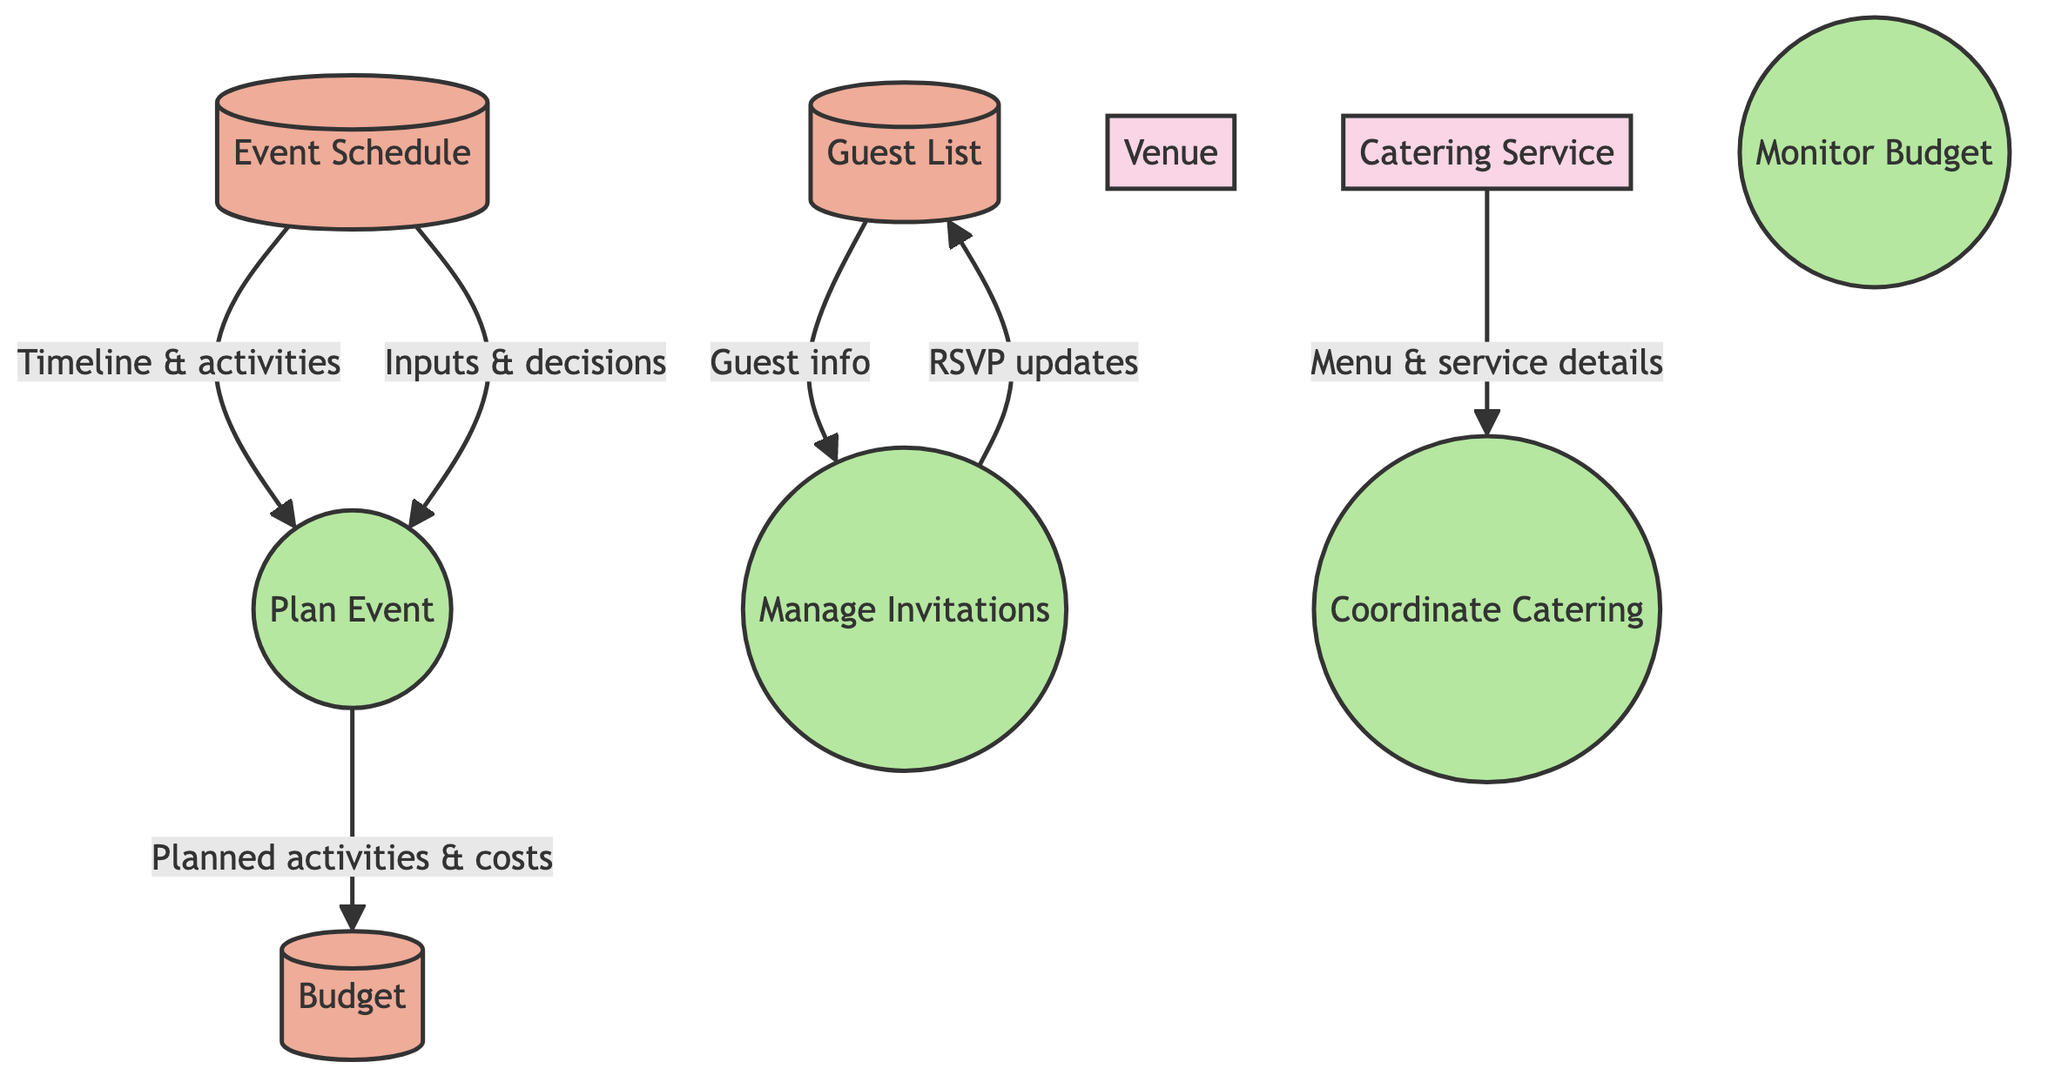What is the primary external entity in this diagram? The primary external entity is Ekaterina Sloeva, as indicated at the top of the diagram. She is the main client and decision-maker for the social gatherings.
Answer: Ekaterina Sloeva How many data stores are present in the diagram? The diagram includes three data stores: Guest List, Event Schedule, and Budget. Counting these nodes gives a total of three.
Answer: 3 What process is responsible for creating and distributing invitations? The Manage Invitations process is designated for handling the creation and distribution of invitations and RSVPs, as shown in the diagram.
Answer: Manage Invitations Which data store receives updates from the Manage Invitations process? The updates from the Manage Invitations process flow into the Guest List data store, as indicated by the arrow in the diagram.
Answer: Guest List How does Ekaterina Sloeva contribute to the Plan Event process? Ekaterina Sloeva inputs her decisions and guidance into the Plan Event process, which is illustrated by the directed flow from her entity to the process.
Answer: Inputs and decisions What type of information does the Event Schedule provide to the Plan Event process? The Event Schedule provides timeline and activity details to the Plan Event process, which facilitates structuring the social gathering.
Answer: Timeline and activities Which external entity provides menu and service details? The Catering Service external entity delivers the menu and service details to the Coordinate Catering process, as represented in the diagram.
Answer: Catering Service What is the purpose of the Monitor Budget process? The Monitor Budget process is intended to track expenditures to ensure that the event remains within the allocated budget, which has been described in the process details.
Answer: Track expenditures What aspect of the planned event updates the Budget data store? The planned activities and their associated costs from the Plan Event process update the Budget data store, noted by the flow in the diagram.
Answer: Planned activities and costs 